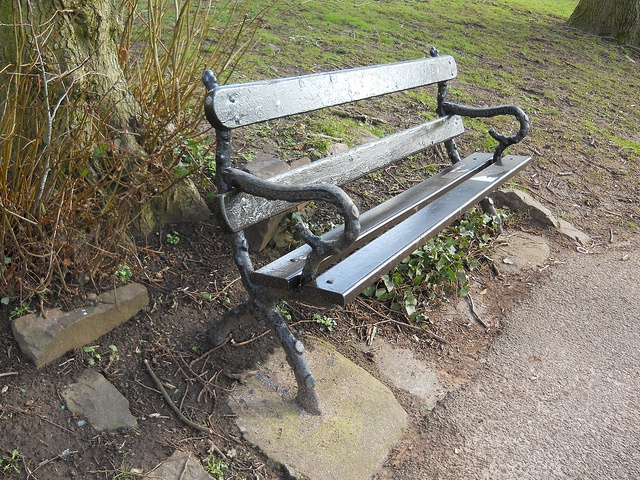Describe the objects in this image and their specific colors. I can see a bench in black, gray, lightgray, and darkgray tones in this image. 